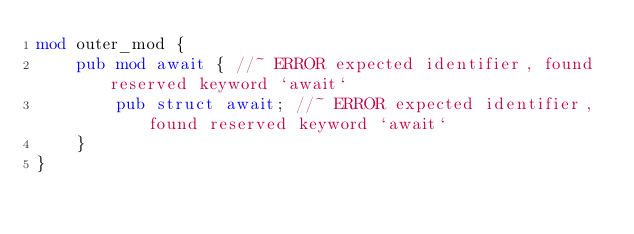<code> <loc_0><loc_0><loc_500><loc_500><_Rust_>mod outer_mod {
    pub mod await { //~ ERROR expected identifier, found reserved keyword `await`
        pub struct await; //~ ERROR expected identifier, found reserved keyword `await`
    }
}</code> 